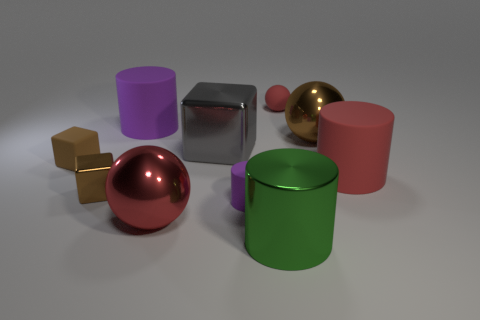There is a big object that is the same color as the tiny cylinder; what is its material?
Your response must be concise. Rubber. How many other objects are the same shape as the gray metal thing?
Your answer should be very brief. 2. Is the large object that is on the right side of the big brown sphere made of the same material as the large brown thing?
Provide a short and direct response. No. Are there the same number of big red balls that are to the right of the small red rubber object and red rubber objects that are behind the gray object?
Your answer should be very brief. No. There is a purple matte thing behind the matte cube; what size is it?
Provide a short and direct response. Large. Is there a tiny blue cylinder that has the same material as the tiny red object?
Keep it short and to the point. No. There is a tiny shiny object that is in front of the large shiny cube; is it the same color as the small rubber cylinder?
Provide a succinct answer. No. Are there the same number of tiny purple matte cylinders in front of the large metal cylinder and tiny purple matte things?
Your answer should be compact. No. Are there any large cylinders of the same color as the big block?
Your response must be concise. No. Does the brown metal block have the same size as the red rubber sphere?
Ensure brevity in your answer.  Yes. 